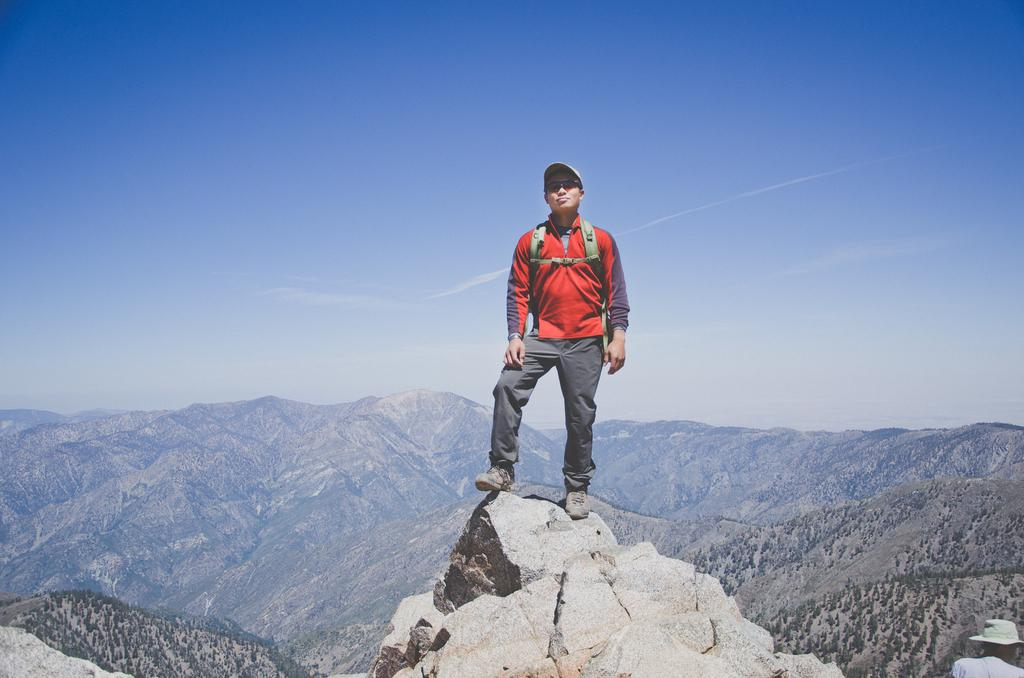What is the person in the image doing? The person is standing on a rock in the image. What can be seen in the background of the image? There are trees and hills visible in the background, as well as clouds in the sky. What type of glass is the person holding in the image? There is no glass present in the image; the person is simply standing on a rock. 